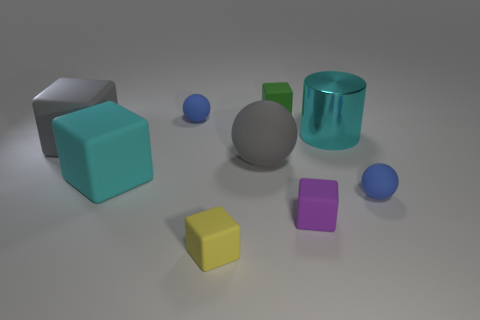What size is the rubber block that is the same color as the metal object?
Offer a terse response. Large. What material is the yellow object that is the same shape as the tiny purple object?
Make the answer very short. Rubber. The small blue rubber thing that is to the left of the cyan thing that is to the right of the matte ball that is behind the big cyan cylinder is what shape?
Your answer should be very brief. Sphere. Is the number of small yellow rubber objects to the right of the big cyan metallic cylinder greater than the number of tiny blue matte spheres?
Ensure brevity in your answer.  No. Do the object in front of the tiny purple matte cube and the purple matte object have the same shape?
Your response must be concise. Yes. What material is the small blue thing on the left side of the green rubber thing?
Keep it short and to the point. Rubber. What number of other large things are the same shape as the yellow thing?
Your answer should be very brief. 2. There is a blue ball that is behind the cylinder behind the purple thing; what is its material?
Make the answer very short. Rubber. There is a matte thing that is the same color as the large sphere; what shape is it?
Keep it short and to the point. Cube. Are there any tiny green objects made of the same material as the big cyan cylinder?
Offer a very short reply. No. 